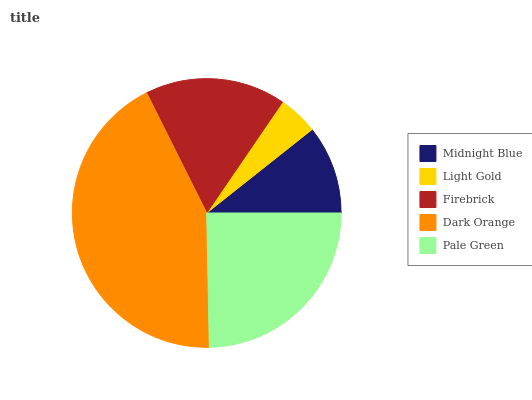Is Light Gold the minimum?
Answer yes or no. Yes. Is Dark Orange the maximum?
Answer yes or no. Yes. Is Firebrick the minimum?
Answer yes or no. No. Is Firebrick the maximum?
Answer yes or no. No. Is Firebrick greater than Light Gold?
Answer yes or no. Yes. Is Light Gold less than Firebrick?
Answer yes or no. Yes. Is Light Gold greater than Firebrick?
Answer yes or no. No. Is Firebrick less than Light Gold?
Answer yes or no. No. Is Firebrick the high median?
Answer yes or no. Yes. Is Firebrick the low median?
Answer yes or no. Yes. Is Midnight Blue the high median?
Answer yes or no. No. Is Pale Green the low median?
Answer yes or no. No. 